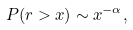<formula> <loc_0><loc_0><loc_500><loc_500>P ( r > x ) \sim x ^ { - \alpha } ,</formula> 